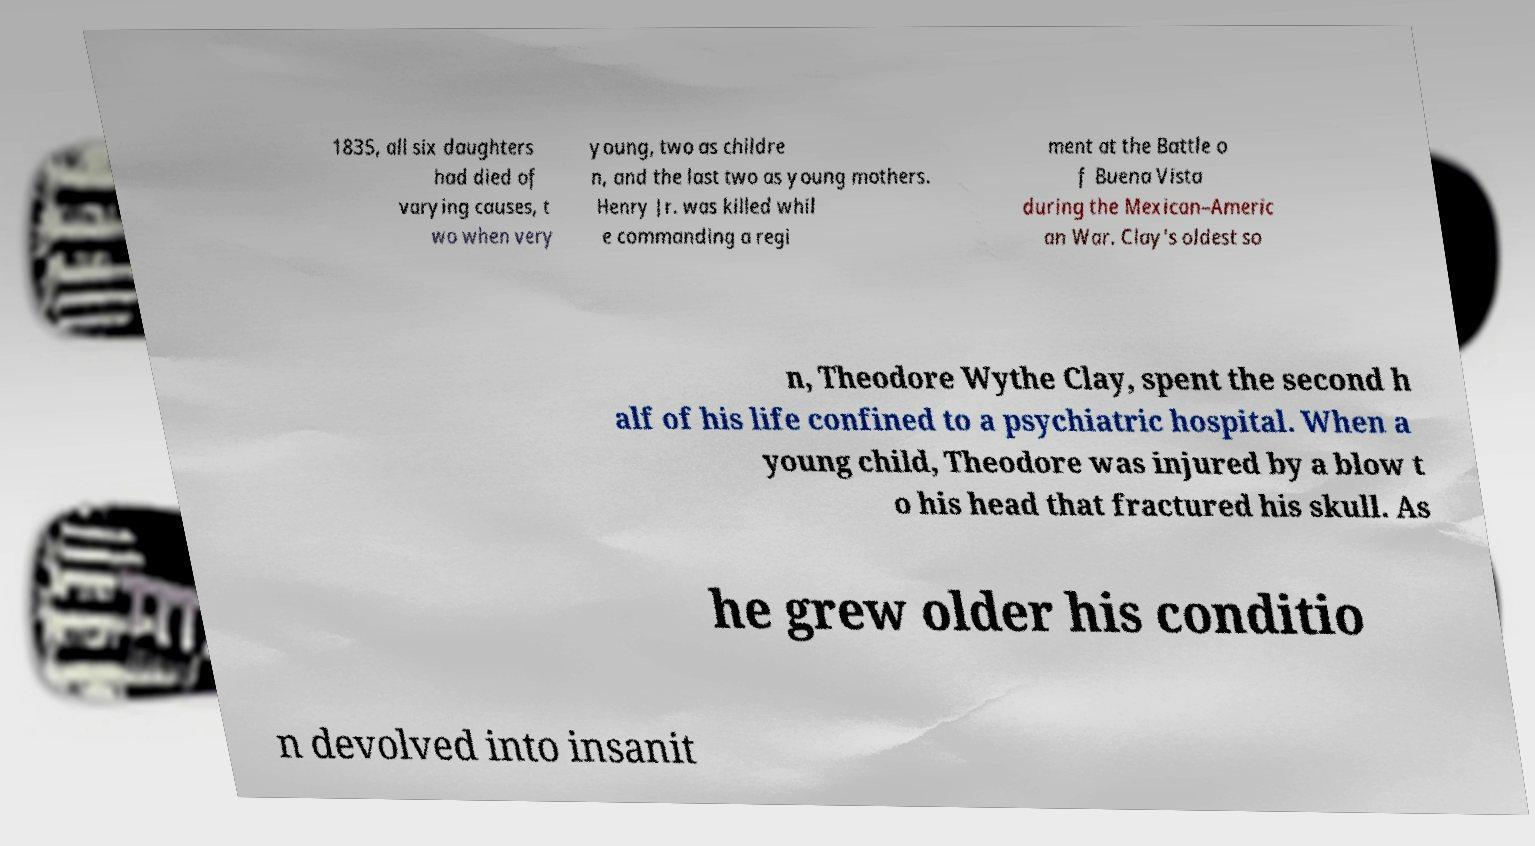Could you assist in decoding the text presented in this image and type it out clearly? 1835, all six daughters had died of varying causes, t wo when very young, two as childre n, and the last two as young mothers. Henry Jr. was killed whil e commanding a regi ment at the Battle o f Buena Vista during the Mexican–Americ an War. Clay's oldest so n, Theodore Wythe Clay, spent the second h alf of his life confined to a psychiatric hospital. When a young child, Theodore was injured by a blow t o his head that fractured his skull. As he grew older his conditio n devolved into insanit 